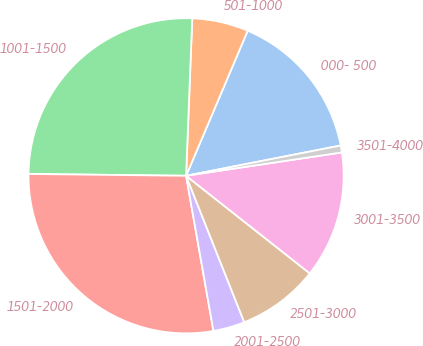Convert chart to OTSL. <chart><loc_0><loc_0><loc_500><loc_500><pie_chart><fcel>000- 500<fcel>501-1000<fcel>1001-1500<fcel>1501-2000<fcel>2001-2500<fcel>2501-3000<fcel>3001-3500<fcel>3501-4000<nl><fcel>15.53%<fcel>5.77%<fcel>25.44%<fcel>27.96%<fcel>3.24%<fcel>8.35%<fcel>13.0%<fcel>0.71%<nl></chart> 